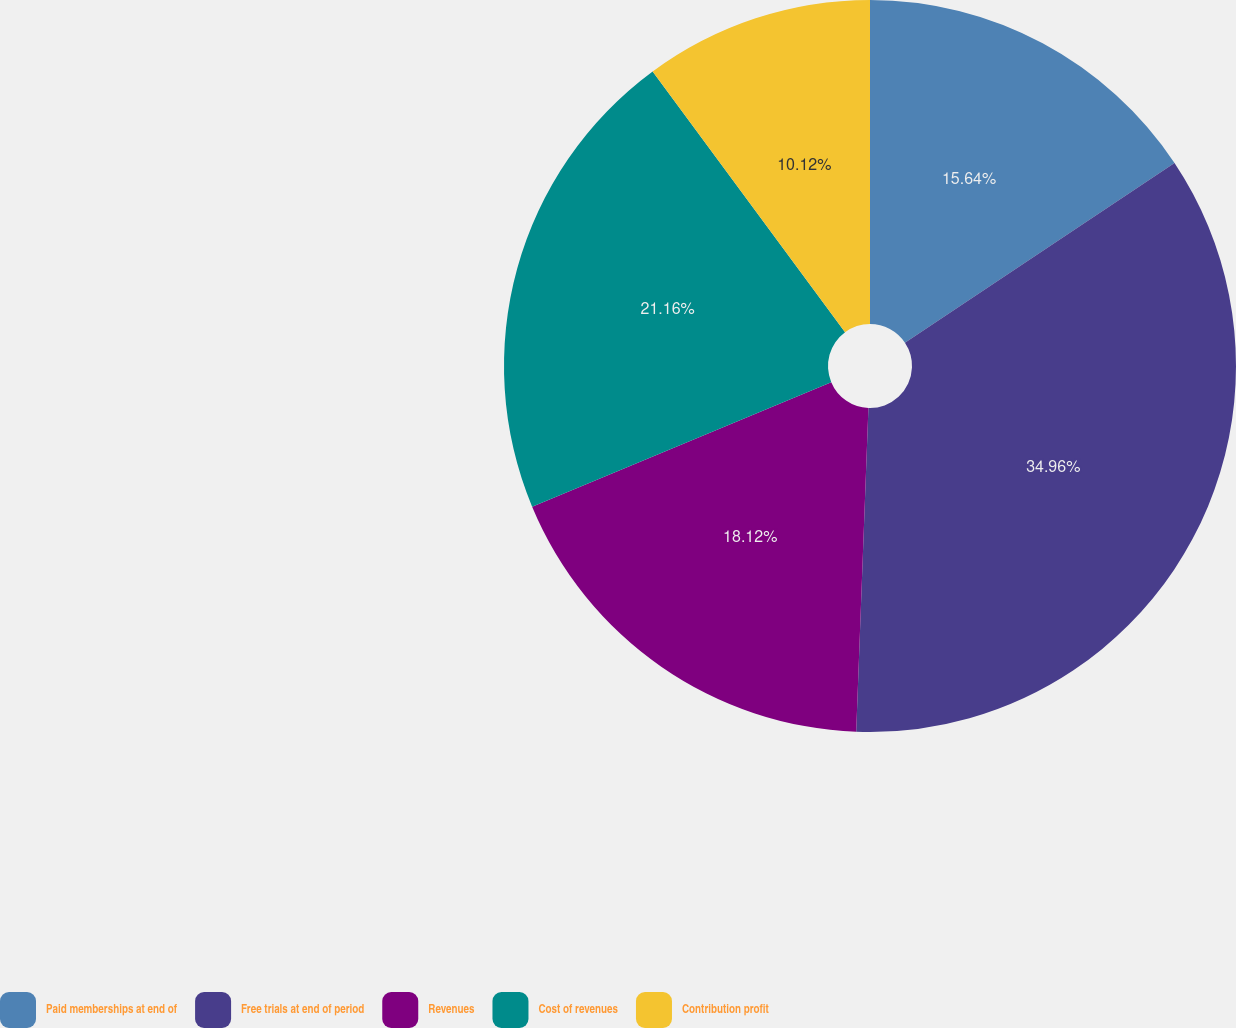Convert chart. <chart><loc_0><loc_0><loc_500><loc_500><pie_chart><fcel>Paid memberships at end of<fcel>Free trials at end of period<fcel>Revenues<fcel>Cost of revenues<fcel>Contribution profit<nl><fcel>15.64%<fcel>34.96%<fcel>18.12%<fcel>21.16%<fcel>10.12%<nl></chart> 